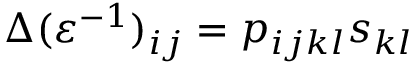<formula> <loc_0><loc_0><loc_500><loc_500>\Delta ( \varepsilon ^ { - 1 } ) _ { i j } = p _ { i j k l } s _ { k l }</formula> 